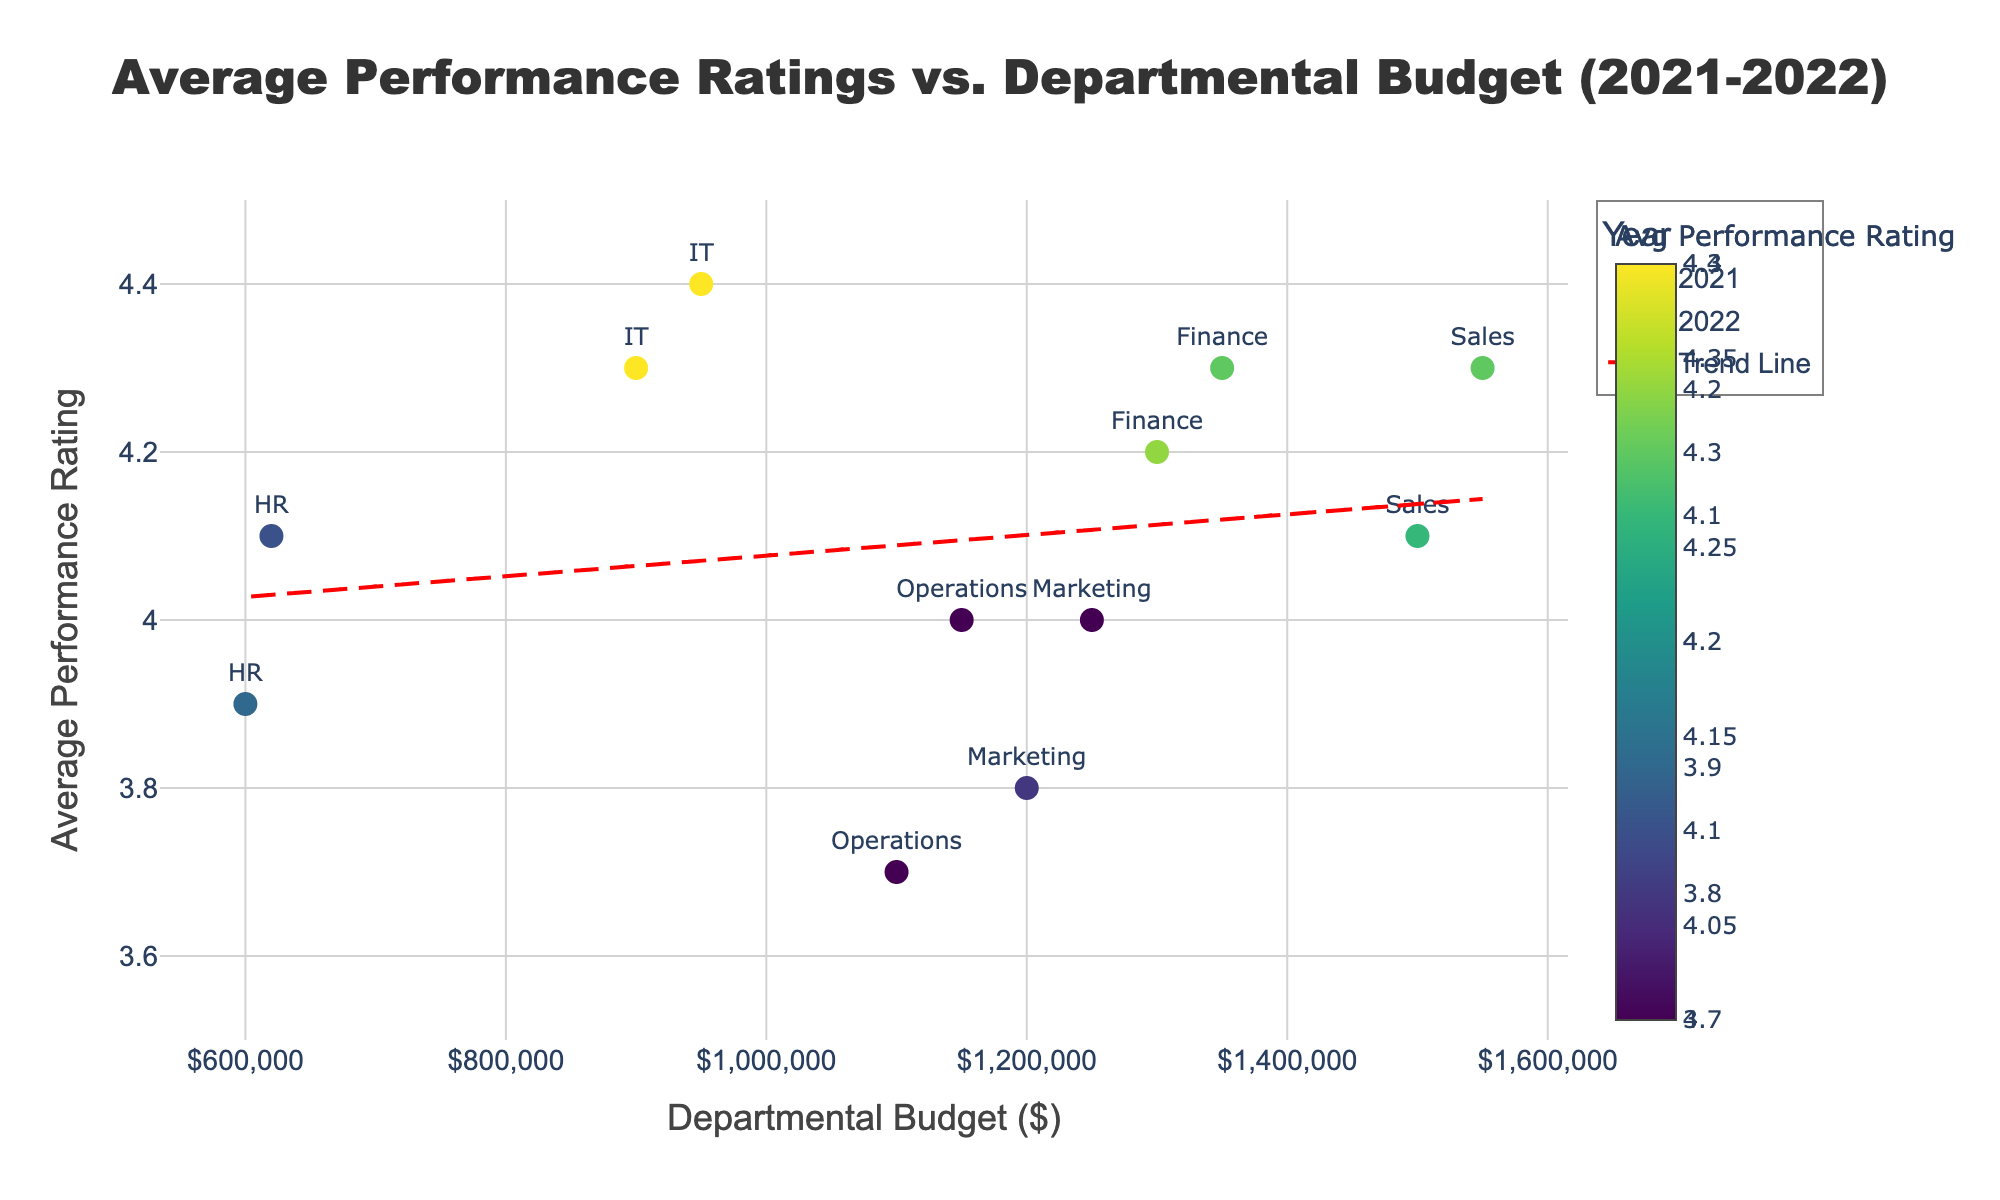Which department had the highest average performance rating in 2022? Identify the year 2022 in the figure. Look for the data point with the highest position along the y-axis within the 2022 group, which corresponds to the highest rating. The highest point for 2022 is IT with a rating of 4.4.
Answer: IT What is the overall trend between departmental budget and average performance rating? The trend line in the figure represents the overall relationship between the budget and performance rating. Observe the direction of the red dashed line. Since it slopes upward, there is a general upward trend indicating higher budgets are associated with higher performance ratings.
Answer: Upward trend Which department had a higher increase in average performance rating from 2021 to 2022: Sales or HR? Find the average performance rating for Sales in 2021 and 2022, then calculate the difference. Repeat for HR. Sales' ratings went from 4.1 to 4.3, an increase of 0.2. HR's ratings went from 3.9 to 4.1, an increase of 0.2.
Answer: Both the same Was the average performance rating of the Finance department above or below the trend line in 2021? Locate the 2021 data point for the Finance department and compare its position to the red dashed trend line. In 2021, the Finance department's rating is at 4.2, which is above the trend line.
Answer: Above How many departments had their average performance ratings increase from 2021 to 2022? Compare the average performance ratings for each department between the two years. Count the number of times the 2022 rating is higher than the 2021 rating. Sales, Marketing, IT, HR, and Operations all improved. Therefore, 5 departments had increases.
Answer: 5 What was the average performance rating of all departments combined in 2022? Add the average performance ratings of all departments in 2022 and divide by the number of departments. The sum is 4.3 + 4.0 + 4.4 + 4.1 + 4.0 + 4.3 = 25.1. Divide by 6 departments.
Answer: 4.18 Which year had a wider range of average performance ratings among departments? Examine the vertical spread (range along the y-axis) for each year. The 2021 ratings range from 3.7 to 4.3 (range = 0.6). The 2022 ratings range from 4.0 to 4.4 (range = 0.4). Therefore, 2021 had a wider range.
Answer: 2021 